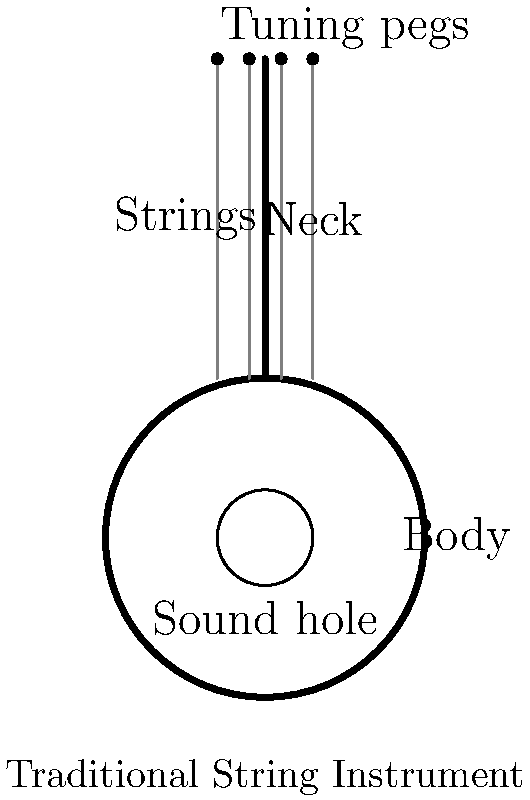In your research on cultural heritage for your manuscript, you come across an exploded view diagram of a traditional string instrument. Identify the component that is responsible for amplifying the sound produced by the vibrating strings. To answer this question, let's analyze the components of the traditional string instrument shown in the diagram:

1. Body: This is the large circular part at the bottom of the instrument. It forms the main resonating chamber.

2. Neck: The long, thin part extending upwards from the body.

3. Strings: The vertical lines running along the neck.

4. Tuning pegs: The small dots at the top of the neck, used for adjusting string tension.

5. Sound hole: The small circle in the center of the body.

The component responsible for amplifying the sound produced by the vibrating strings is the body of the instrument. Here's why:

1. When the strings vibrate, they produce sound waves.
2. These sound waves enter the body of the instrument through the bridge (not shown in this simplified diagram but typically located between the sound hole and the bottom of the strings).
3. The body acts as a resonating chamber, amplifying and enriching the sound.
4. The sound hole allows the amplified sound to project outward, making it audible to listeners.

The body's shape, size, and material all contribute to the instrument's unique tone and volume. In many traditional string instruments, the craftsmanship of the body is crucial to the overall sound quality.
Answer: Body 